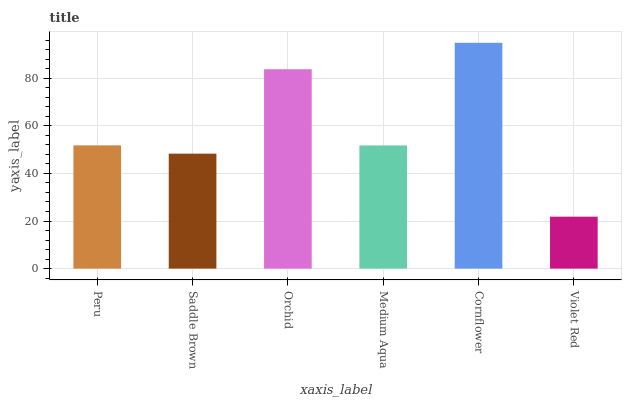Is Violet Red the minimum?
Answer yes or no. Yes. Is Cornflower the maximum?
Answer yes or no. Yes. Is Saddle Brown the minimum?
Answer yes or no. No. Is Saddle Brown the maximum?
Answer yes or no. No. Is Peru greater than Saddle Brown?
Answer yes or no. Yes. Is Saddle Brown less than Peru?
Answer yes or no. Yes. Is Saddle Brown greater than Peru?
Answer yes or no. No. Is Peru less than Saddle Brown?
Answer yes or no. No. Is Peru the high median?
Answer yes or no. Yes. Is Medium Aqua the low median?
Answer yes or no. Yes. Is Saddle Brown the high median?
Answer yes or no. No. Is Orchid the low median?
Answer yes or no. No. 